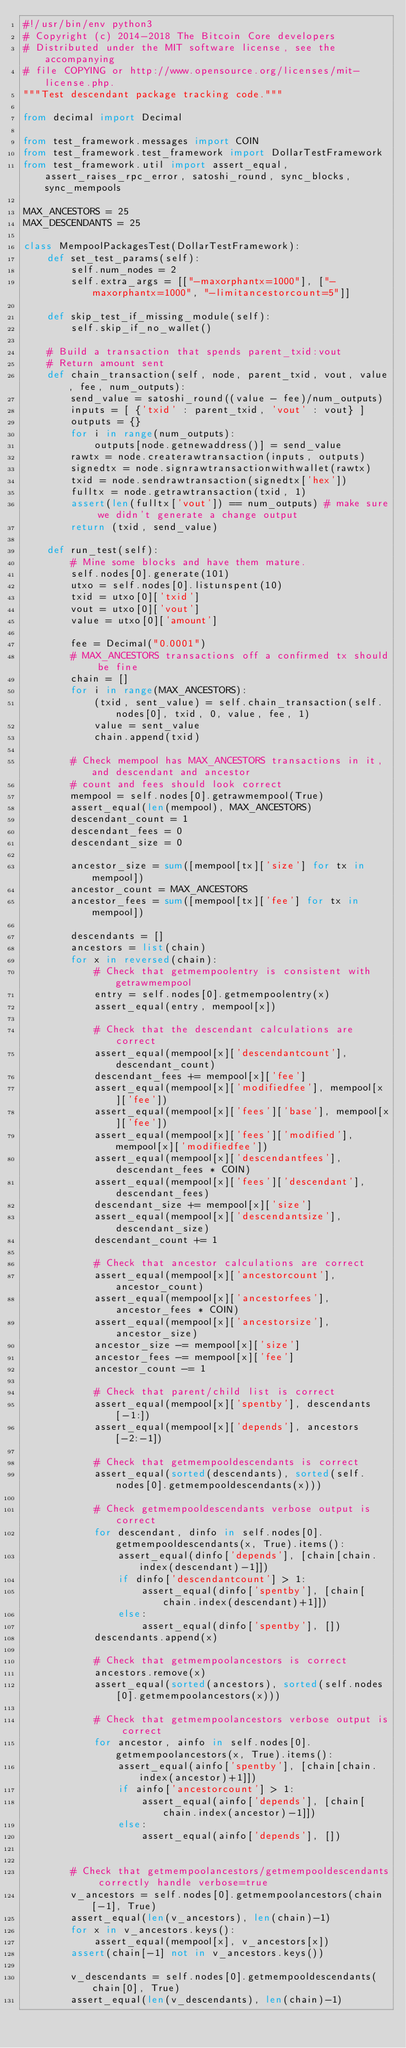Convert code to text. <code><loc_0><loc_0><loc_500><loc_500><_Python_>#!/usr/bin/env python3
# Copyright (c) 2014-2018 The Bitcoin Core developers
# Distributed under the MIT software license, see the accompanying
# file COPYING or http://www.opensource.org/licenses/mit-license.php.
"""Test descendant package tracking code."""

from decimal import Decimal

from test_framework.messages import COIN
from test_framework.test_framework import DollarTestFramework
from test_framework.util import assert_equal, assert_raises_rpc_error, satoshi_round, sync_blocks, sync_mempools

MAX_ANCESTORS = 25
MAX_DESCENDANTS = 25

class MempoolPackagesTest(DollarTestFramework):
    def set_test_params(self):
        self.num_nodes = 2
        self.extra_args = [["-maxorphantx=1000"], ["-maxorphantx=1000", "-limitancestorcount=5"]]

    def skip_test_if_missing_module(self):
        self.skip_if_no_wallet()

    # Build a transaction that spends parent_txid:vout
    # Return amount sent
    def chain_transaction(self, node, parent_txid, vout, value, fee, num_outputs):
        send_value = satoshi_round((value - fee)/num_outputs)
        inputs = [ {'txid' : parent_txid, 'vout' : vout} ]
        outputs = {}
        for i in range(num_outputs):
            outputs[node.getnewaddress()] = send_value
        rawtx = node.createrawtransaction(inputs, outputs)
        signedtx = node.signrawtransactionwithwallet(rawtx)
        txid = node.sendrawtransaction(signedtx['hex'])
        fulltx = node.getrawtransaction(txid, 1)
        assert(len(fulltx['vout']) == num_outputs) # make sure we didn't generate a change output
        return (txid, send_value)

    def run_test(self):
        # Mine some blocks and have them mature.
        self.nodes[0].generate(101)
        utxo = self.nodes[0].listunspent(10)
        txid = utxo[0]['txid']
        vout = utxo[0]['vout']
        value = utxo[0]['amount']

        fee = Decimal("0.0001")
        # MAX_ANCESTORS transactions off a confirmed tx should be fine
        chain = []
        for i in range(MAX_ANCESTORS):
            (txid, sent_value) = self.chain_transaction(self.nodes[0], txid, 0, value, fee, 1)
            value = sent_value
            chain.append(txid)

        # Check mempool has MAX_ANCESTORS transactions in it, and descendant and ancestor
        # count and fees should look correct
        mempool = self.nodes[0].getrawmempool(True)
        assert_equal(len(mempool), MAX_ANCESTORS)
        descendant_count = 1
        descendant_fees = 0
        descendant_size = 0

        ancestor_size = sum([mempool[tx]['size'] for tx in mempool])
        ancestor_count = MAX_ANCESTORS
        ancestor_fees = sum([mempool[tx]['fee'] for tx in mempool])

        descendants = []
        ancestors = list(chain)
        for x in reversed(chain):
            # Check that getmempoolentry is consistent with getrawmempool
            entry = self.nodes[0].getmempoolentry(x)
            assert_equal(entry, mempool[x])

            # Check that the descendant calculations are correct
            assert_equal(mempool[x]['descendantcount'], descendant_count)
            descendant_fees += mempool[x]['fee']
            assert_equal(mempool[x]['modifiedfee'], mempool[x]['fee'])
            assert_equal(mempool[x]['fees']['base'], mempool[x]['fee'])
            assert_equal(mempool[x]['fees']['modified'], mempool[x]['modifiedfee'])
            assert_equal(mempool[x]['descendantfees'], descendant_fees * COIN)
            assert_equal(mempool[x]['fees']['descendant'], descendant_fees)
            descendant_size += mempool[x]['size']
            assert_equal(mempool[x]['descendantsize'], descendant_size)
            descendant_count += 1

            # Check that ancestor calculations are correct
            assert_equal(mempool[x]['ancestorcount'], ancestor_count)
            assert_equal(mempool[x]['ancestorfees'], ancestor_fees * COIN)
            assert_equal(mempool[x]['ancestorsize'], ancestor_size)
            ancestor_size -= mempool[x]['size']
            ancestor_fees -= mempool[x]['fee']
            ancestor_count -= 1

            # Check that parent/child list is correct
            assert_equal(mempool[x]['spentby'], descendants[-1:])
            assert_equal(mempool[x]['depends'], ancestors[-2:-1])

            # Check that getmempooldescendants is correct
            assert_equal(sorted(descendants), sorted(self.nodes[0].getmempooldescendants(x)))

            # Check getmempooldescendants verbose output is correct
            for descendant, dinfo in self.nodes[0].getmempooldescendants(x, True).items():
                assert_equal(dinfo['depends'], [chain[chain.index(descendant)-1]])
                if dinfo['descendantcount'] > 1:
                    assert_equal(dinfo['spentby'], [chain[chain.index(descendant)+1]])
                else:
                    assert_equal(dinfo['spentby'], [])
            descendants.append(x)

            # Check that getmempoolancestors is correct
            ancestors.remove(x)
            assert_equal(sorted(ancestors), sorted(self.nodes[0].getmempoolancestors(x)))

            # Check that getmempoolancestors verbose output is correct
            for ancestor, ainfo in self.nodes[0].getmempoolancestors(x, True).items():
                assert_equal(ainfo['spentby'], [chain[chain.index(ancestor)+1]])
                if ainfo['ancestorcount'] > 1:
                    assert_equal(ainfo['depends'], [chain[chain.index(ancestor)-1]])
                else:
                    assert_equal(ainfo['depends'], [])


        # Check that getmempoolancestors/getmempooldescendants correctly handle verbose=true
        v_ancestors = self.nodes[0].getmempoolancestors(chain[-1], True)
        assert_equal(len(v_ancestors), len(chain)-1)
        for x in v_ancestors.keys():
            assert_equal(mempool[x], v_ancestors[x])
        assert(chain[-1] not in v_ancestors.keys())

        v_descendants = self.nodes[0].getmempooldescendants(chain[0], True)
        assert_equal(len(v_descendants), len(chain)-1)</code> 